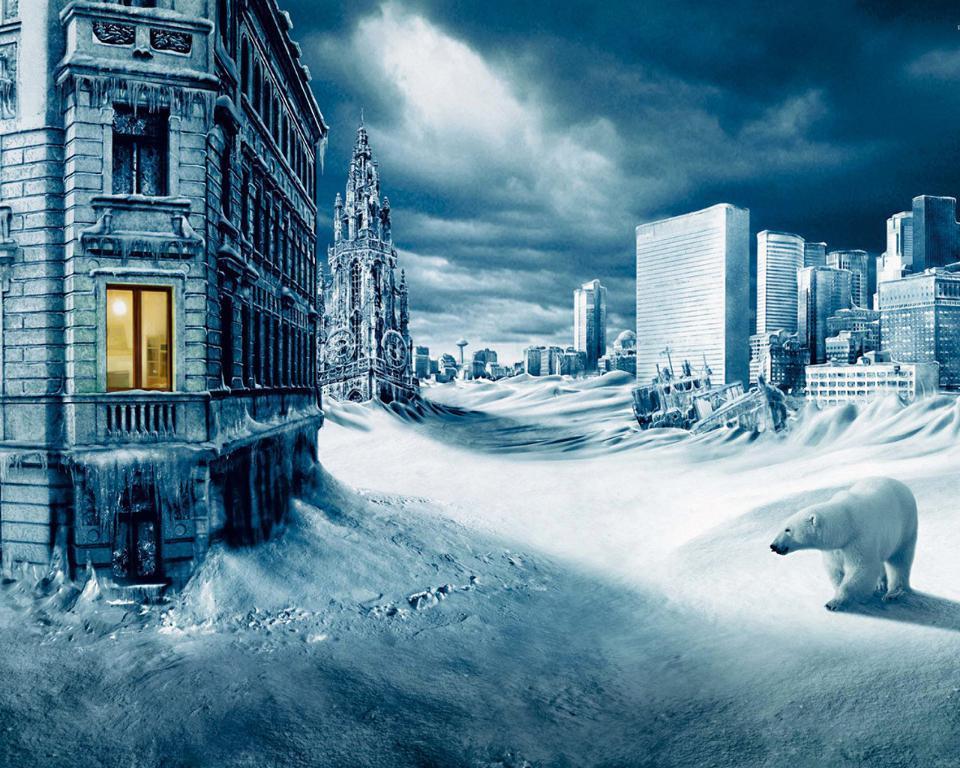Could you give a brief overview of what you see in this image? In this image I can see some snow on the ground, a polar bear which is black and white in color on the snow and few buildings which are white and black in color. I can see the window of the building through which I can see a light. In the background I can see the sky and few buildings. 